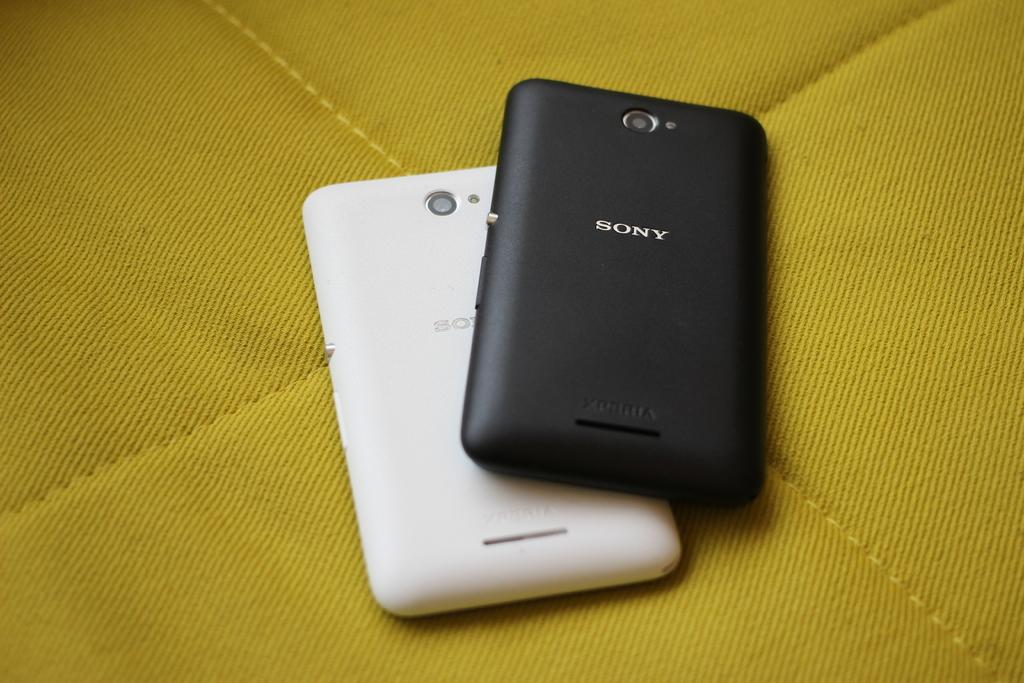<image>
Describe the image concisely. A white and a black phone made by SONY. 